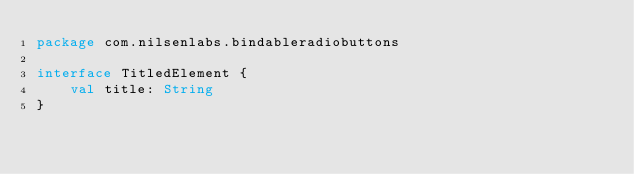<code> <loc_0><loc_0><loc_500><loc_500><_Kotlin_>package com.nilsenlabs.bindableradiobuttons

interface TitledElement {
    val title: String
}</code> 